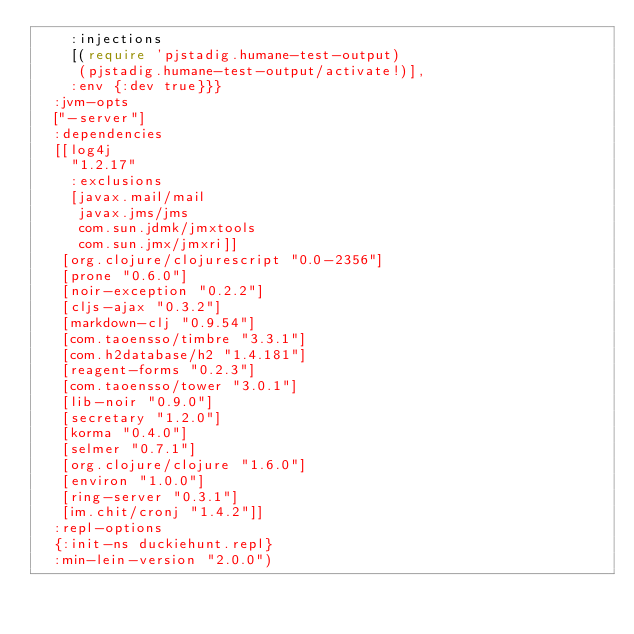<code> <loc_0><loc_0><loc_500><loc_500><_Clojure_>    :injections
    [(require 'pjstadig.humane-test-output)
     (pjstadig.humane-test-output/activate!)],
    :env {:dev true}}}
  :jvm-opts
  ["-server"]
  :dependencies
  [[log4j
    "1.2.17"
    :exclusions
    [javax.mail/mail
     javax.jms/jms
     com.sun.jdmk/jmxtools
     com.sun.jmx/jmxri]]
   [org.clojure/clojurescript "0.0-2356"]
   [prone "0.6.0"]
   [noir-exception "0.2.2"]
   [cljs-ajax "0.3.2"]
   [markdown-clj "0.9.54"]
   [com.taoensso/timbre "3.3.1"]
   [com.h2database/h2 "1.4.181"]
   [reagent-forms "0.2.3"]
   [com.taoensso/tower "3.0.1"]
   [lib-noir "0.9.0"]
   [secretary "1.2.0"]
   [korma "0.4.0"]
   [selmer "0.7.1"]
   [org.clojure/clojure "1.6.0"]
   [environ "1.0.0"]
   [ring-server "0.3.1"]
   [im.chit/cronj "1.4.2"]]
  :repl-options
  {:init-ns duckiehunt.repl}
  :min-lein-version "2.0.0")</code> 